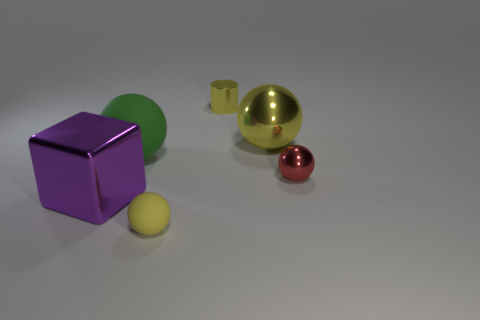Subtract all cylinders. How many objects are left? 5 Subtract 1 balls. How many balls are left? 3 Subtract all brown cylinders. Subtract all blue spheres. How many cylinders are left? 1 Subtract all gray cubes. How many yellow spheres are left? 2 Subtract all large yellow things. Subtract all large yellow spheres. How many objects are left? 4 Add 5 small yellow rubber balls. How many small yellow rubber balls are left? 6 Add 5 big blue cylinders. How many big blue cylinders exist? 5 Add 2 red things. How many objects exist? 8 Subtract all red spheres. How many spheres are left? 3 Subtract 0 brown balls. How many objects are left? 6 